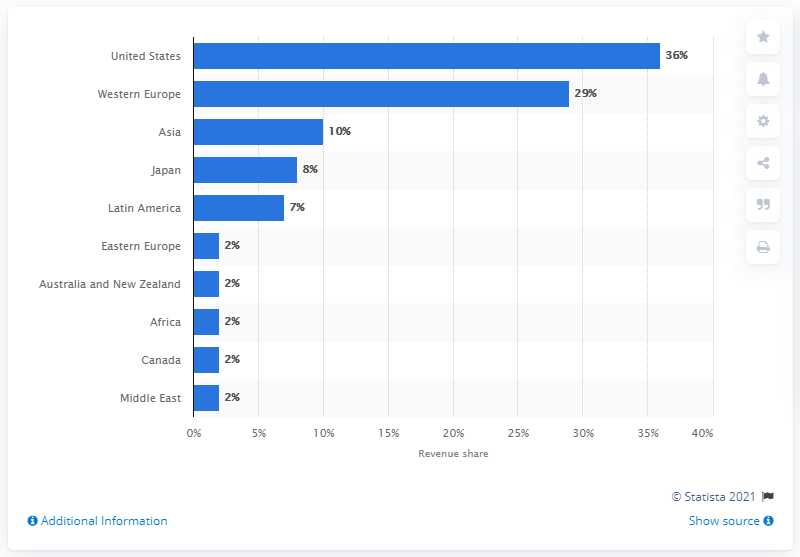Identify some key points in this picture. In 2010, Western Europe held a significant share of the wastewater treatment works and utilities market, at 29%. 